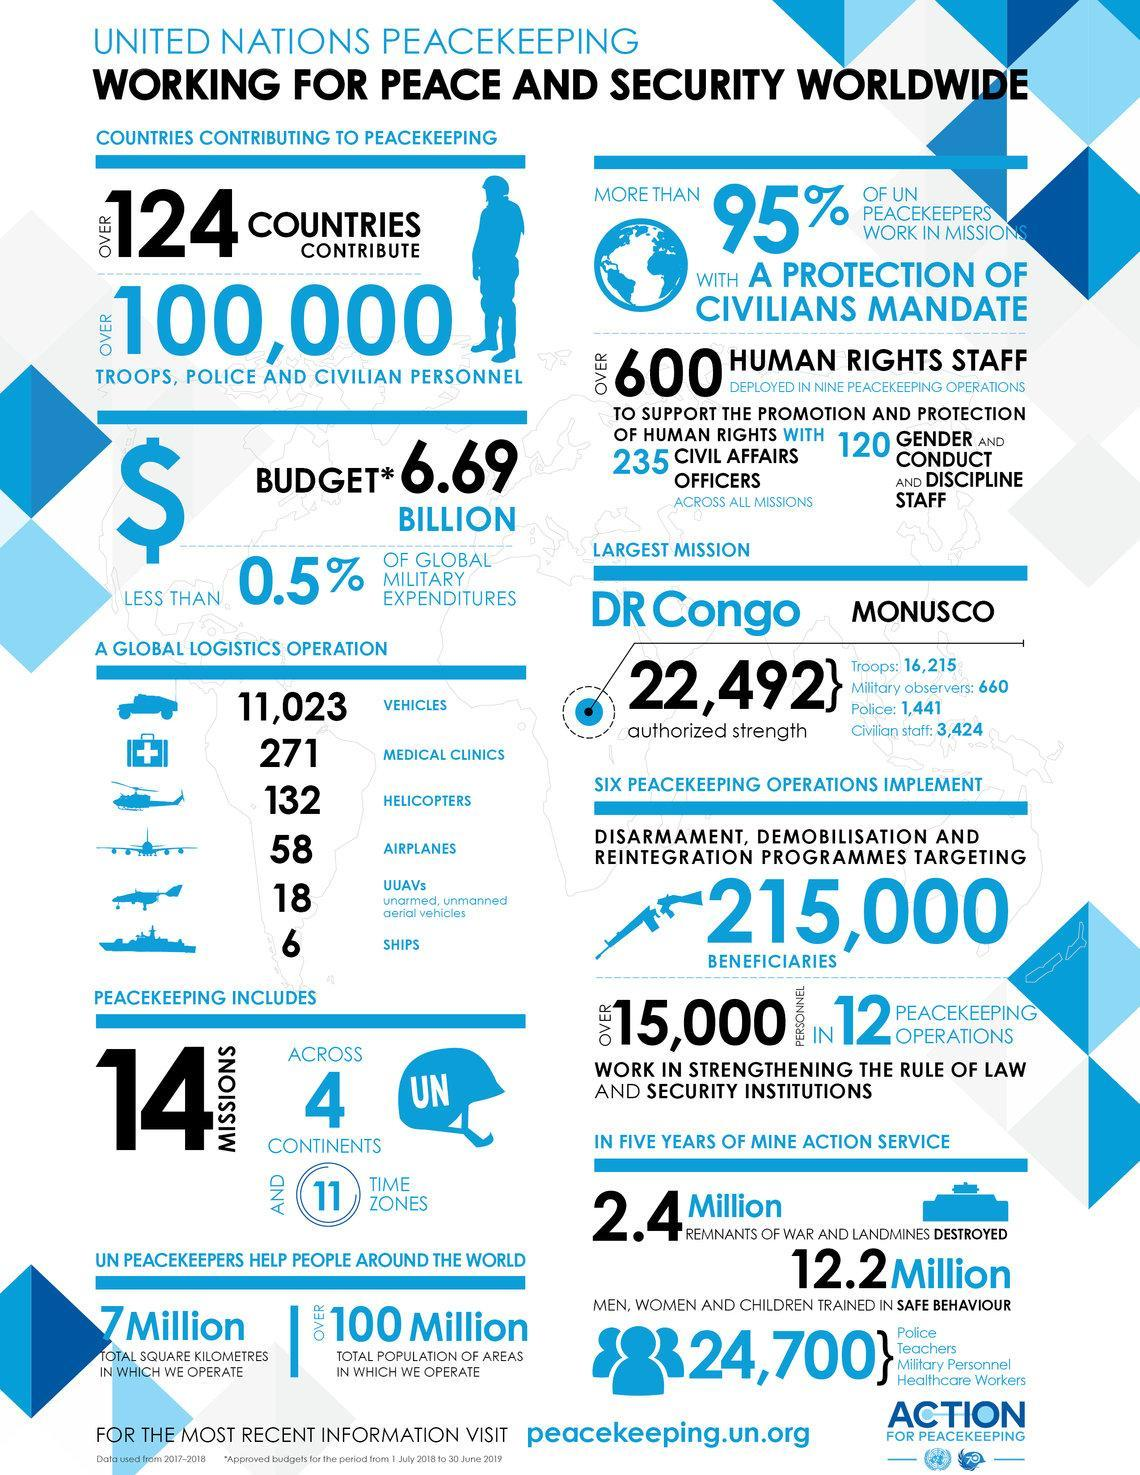What is the total number of forces deployed for the UN mission in Monusco?
Answer the question with a short phrase. 22,492 How many countries contribute to the UN peace keeping missions? OVER 124 COUNTRIES How many civilian staffs were deployed for the UN mission in Monusco? 3,424 What is the total population of areas in which the UN peace keepers operate? OVER 100 Million What is the total budget for the UN peace keeping missions in dollars? 6.69 BILLION How many military observers were deployed for the UN mission in Monusco? 660 How many troops were deployed for the UN mission in Monusco? 16,215 How many UN peace keeping missions were deployed across different continents? 14 